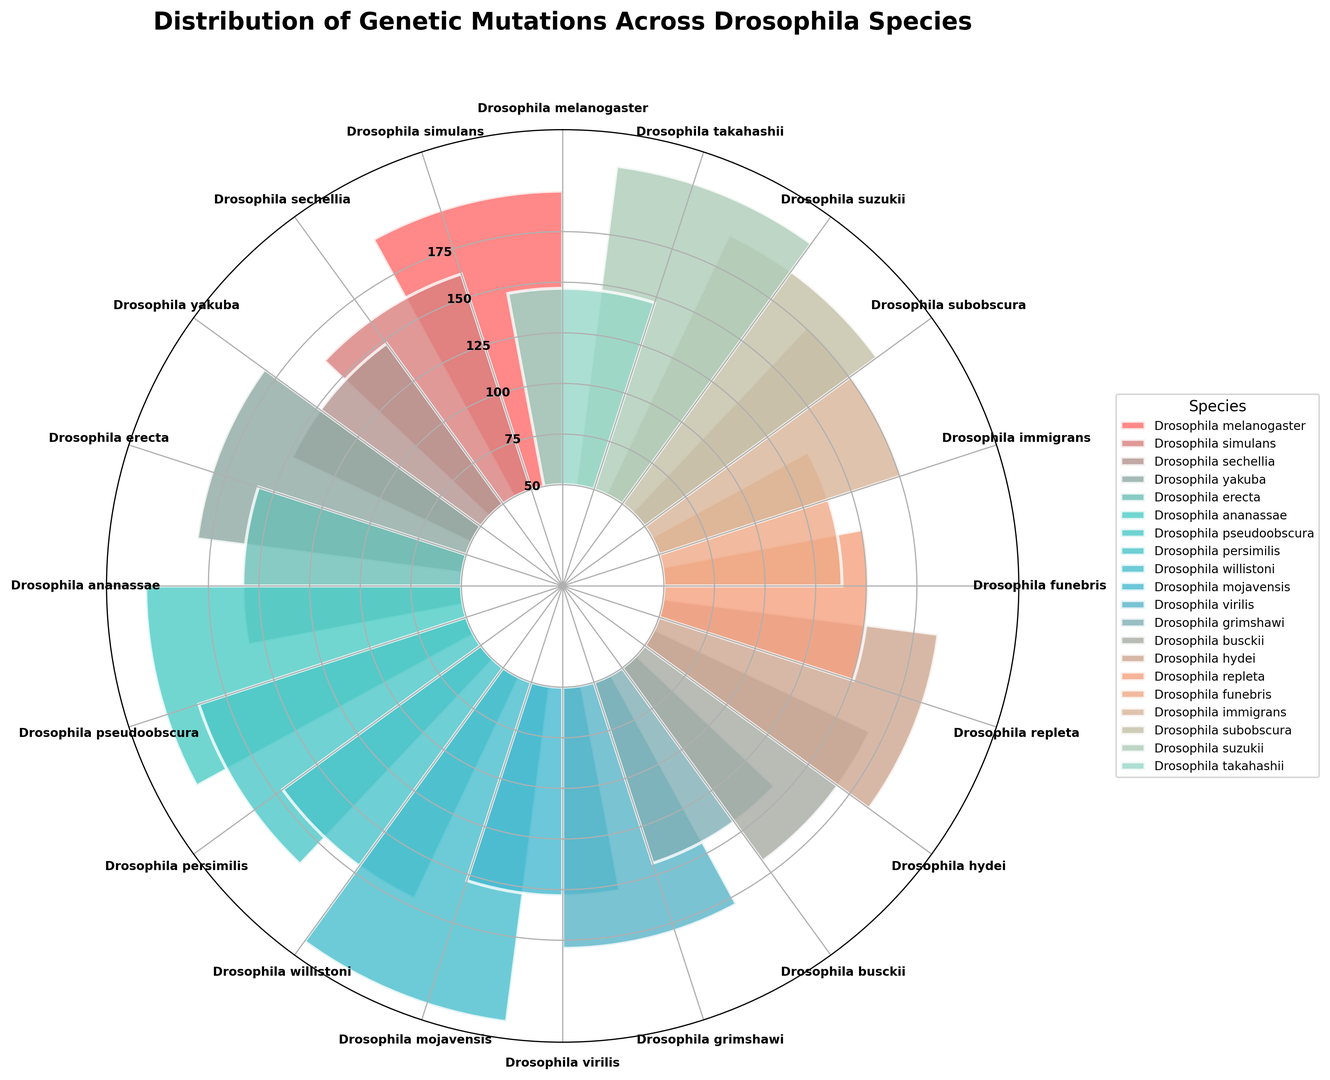How many Drosophila species have mutation counts greater than 150? To find this, identify the bars in the rose chart that extend beyond the 150-mark on the radial axis. Count those species.
Answer: 4 Which species has the highest mutation count? Look for the tallest bar in the rose chart as it represents the species with the highest mutation count. Read the label associated with that bar.
Answer: Drosophila willistoni What is the total mutation count for Drosophila melanogaster, Drosophila simulans, and Drosophila sechellia? Sum the mutation counts for these three species: Drosophila melanogaster (145), Drosophila simulans (112), and Drosophila sechellia (98). The calculation is 145 + 112 + 98.
Answer: 355 Which species has fewer mutation counts than Drosophila yakuba but more than Drosophila mojavensis? Identify the species on the chart that has bars between the heights corresponding to Drosophila yakuba (132) and Drosophila mojavensis (103).
Answer: Drosophila simulans, Drosophila erecta, Drosophila persimilis What is the difference in mutation count between Drosophila pseudoobscura and Drosophila repleta? Calculate the difference by subtracting the mutation count of Drosophila repleta (101) from that of Drosophila pseudoobscura (139).
Answer: 38 What is the average mutation count of the species depicted in the rose chart? Sum all the mutation counts and divide by the number of species. The calculation is (145 + 112 + 98 + 132 + 108 + 156 + 139 + 121 + 167 + 103 + 129 + 94 + 118 + 137 + 101 + 88 + 126 + 142 + 159 + 97) / 20.
Answer: 126.25 Which species has a mutation count closest to the mean mutation count of all 20 species? Calculate the mean mutation count (126.25) and identify the species with a mutation count closest to this value.
Answer: Drosophila virilis (129) Are there any species with mutation counts below 100? If so, which ones? Identify the bars that are shorter than the 100-mark on the radial axis in the rose chart. Read the species names associated with those bars.
Answer: Drosophila sechellia, Drosophila grimshawi, Drosophila funebris, Drosophila takahashii Which species has a mutation count equal to or more than the mutation count of Drosophila ananassae? Locate the bar representing Drosophila ananassae (156) and identify the species with equal to or taller bars.
Answer: Drosophila suzukii (159), Drosophila willistoni (167) What is the mutation spread between the species with the highest and lowest mutation counts? Identify the highest (Drosophila willistoni, 167) and lowest (Drosophila funebris, 88) mutation counts and calculate the difference.
Answer: 79 